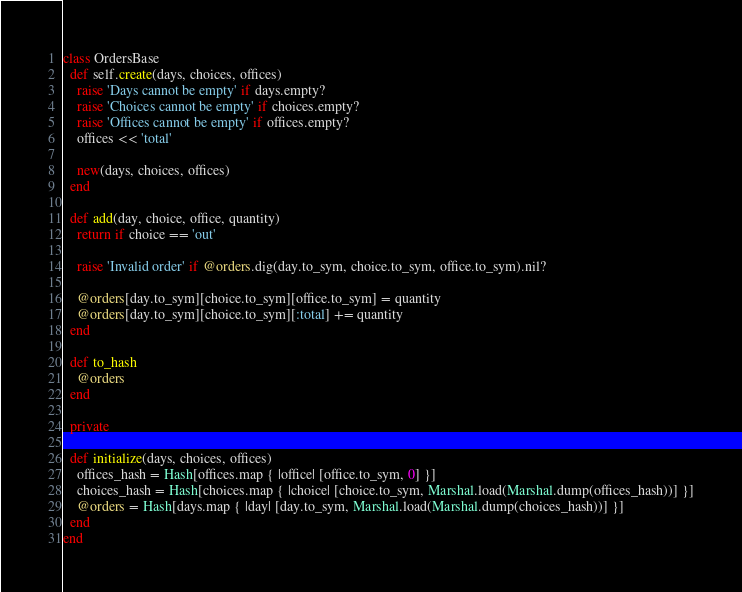Convert code to text. <code><loc_0><loc_0><loc_500><loc_500><_Ruby_>class OrdersBase
  def self.create(days, choices, offices)
    raise 'Days cannot be empty' if days.empty?
    raise 'Choices cannot be empty' if choices.empty?
    raise 'Offices cannot be empty' if offices.empty?
    offices << 'total'

    new(days, choices, offices)
  end

  def add(day, choice, office, quantity)
    return if choice == 'out'

    raise 'Invalid order' if @orders.dig(day.to_sym, choice.to_sym, office.to_sym).nil?

    @orders[day.to_sym][choice.to_sym][office.to_sym] = quantity
    @orders[day.to_sym][choice.to_sym][:total] += quantity
  end

  def to_hash
    @orders
  end

  private

  def initialize(days, choices, offices)
    offices_hash = Hash[offices.map { |office| [office.to_sym, 0] }]
    choices_hash = Hash[choices.map { |choice| [choice.to_sym, Marshal.load(Marshal.dump(offices_hash))] }]
    @orders = Hash[days.map { |day| [day.to_sym, Marshal.load(Marshal.dump(choices_hash))] }]
  end
end
</code> 